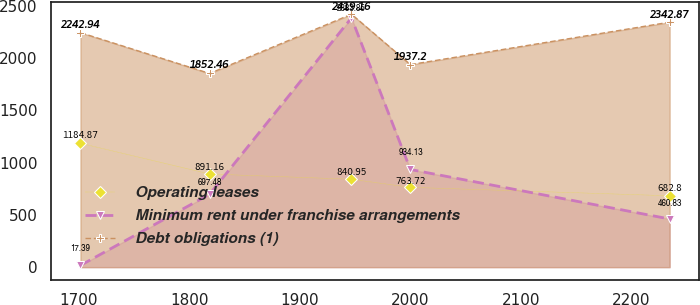Convert chart to OTSL. <chart><loc_0><loc_0><loc_500><loc_500><line_chart><ecel><fcel>Operating leases<fcel>Minimum rent under franchise arrangements<fcel>Debt obligations (1)<nl><fcel>1701.53<fcel>1184.87<fcel>17.39<fcel>2242.94<nl><fcel>1818.43<fcel>891.16<fcel>697.48<fcel>1852.46<nl><fcel>1946.86<fcel>840.95<fcel>2383.85<fcel>2419.16<nl><fcel>2000.19<fcel>763.72<fcel>934.13<fcel>1937.2<nl><fcel>2234.88<fcel>682.8<fcel>460.83<fcel>2342.87<nl></chart> 